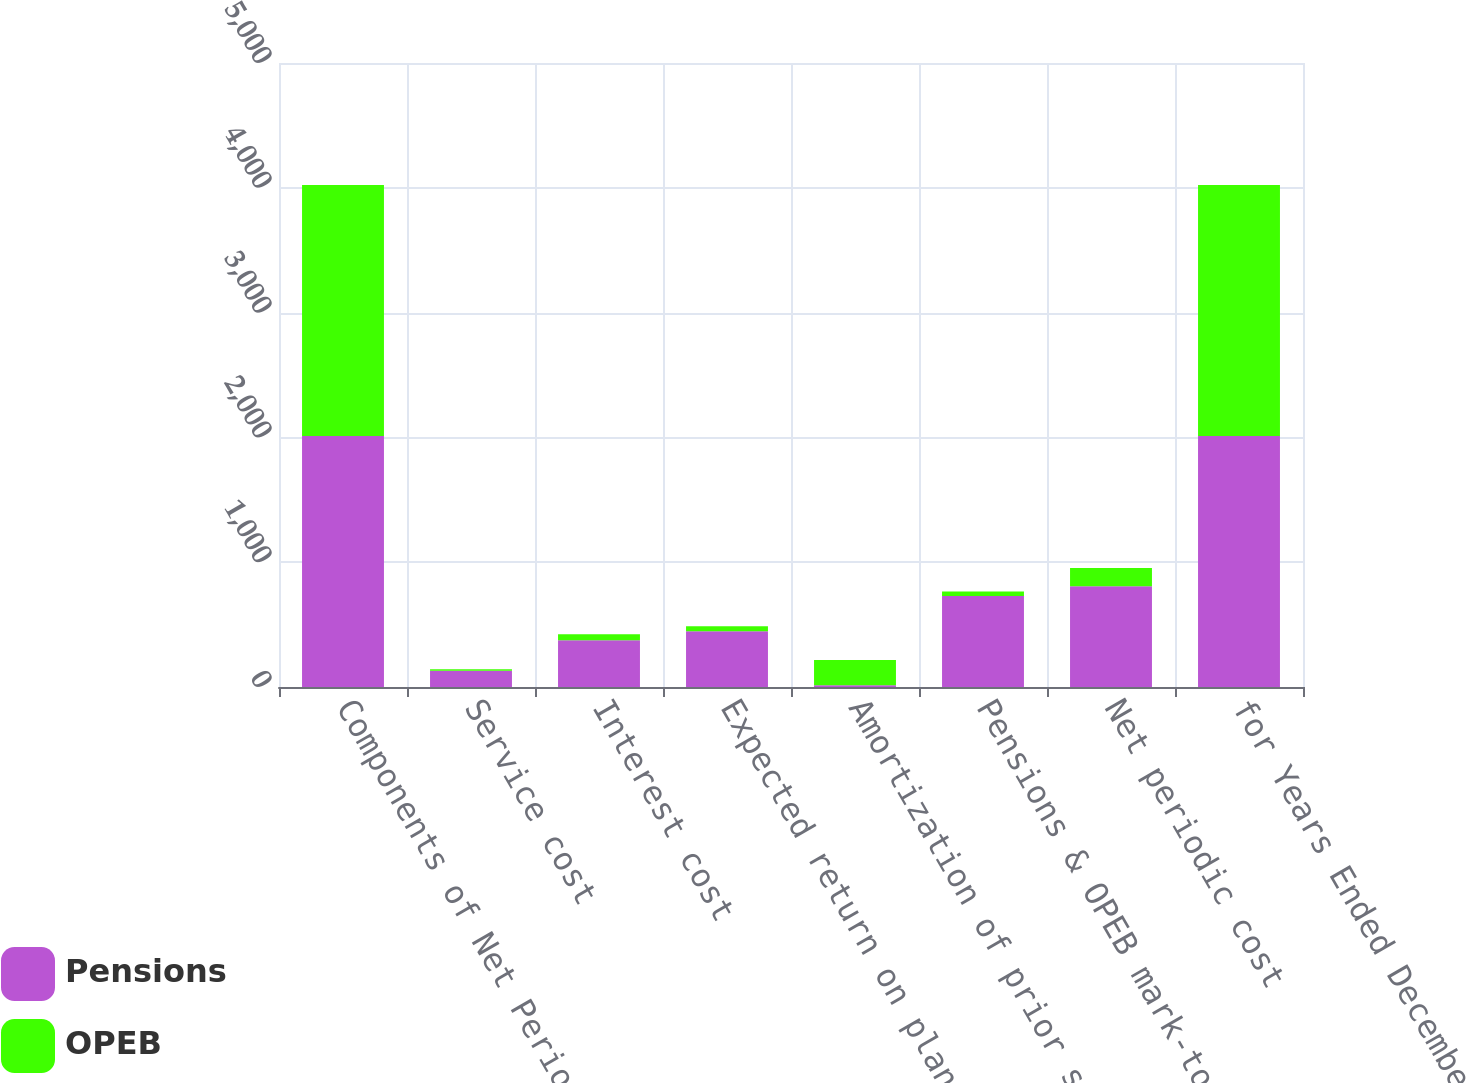Convert chart to OTSL. <chart><loc_0><loc_0><loc_500><loc_500><stacked_bar_chart><ecel><fcel>Components of Net Periodic<fcel>Service cost<fcel>Interest cost<fcel>Expected return on plan assets<fcel>Amortization of prior service<fcel>Pensions & OPEB mark-to-market<fcel>Net periodic cost<fcel>for Years Ended December 31<nl><fcel>Pensions<fcel>2011<fcel>130<fcel>374<fcel>446<fcel>14<fcel>729<fcel>807<fcel>2011<nl><fcel>OPEB<fcel>2011<fcel>13<fcel>48<fcel>40<fcel>203<fcel>36<fcel>146<fcel>2011<nl></chart> 